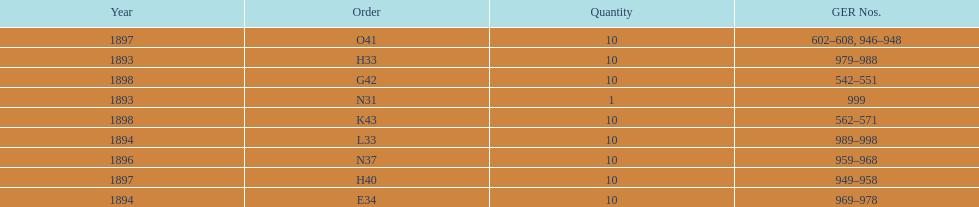What is the total number of locomotives made during this time? 81. 